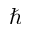Convert formula to latex. <formula><loc_0><loc_0><loc_500><loc_500>\hbar</formula> 